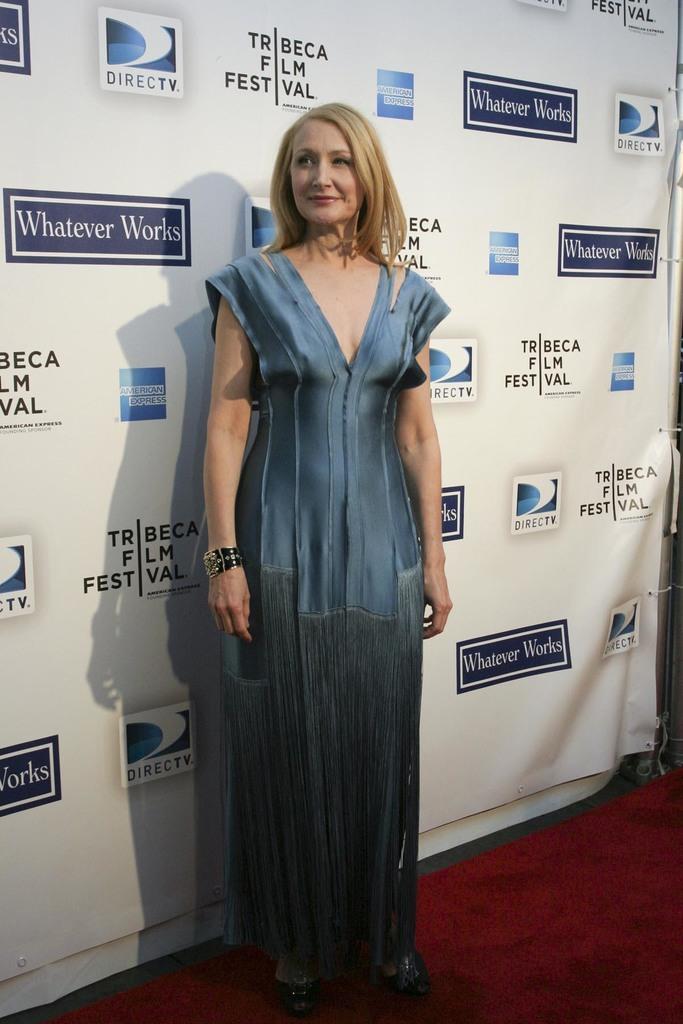Can you describe this image briefly? In this image there is a woman standing and posing for the camera, behind the woman there is a banner. 